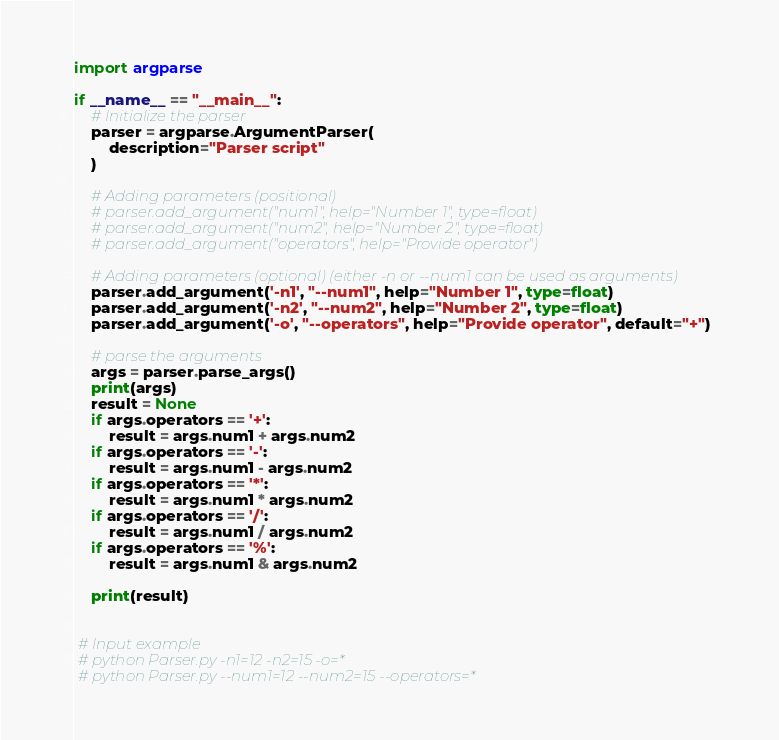Convert code to text. <code><loc_0><loc_0><loc_500><loc_500><_Python_>import argparse

if __name__ == "__main__":
    # Initialize the parser
    parser = argparse.ArgumentParser(
        description="Parser script"
    )

    # Adding parameters (positional)
    # parser.add_argument("num1", help="Number 1", type=float)
    # parser.add_argument("num2", help="Number 2", type=float)
    # parser.add_argument("operators", help="Provide operator")

    # Adding parameters (optional) (either -n or --num1 can be used as arguments)
    parser.add_argument('-n1', "--num1", help="Number 1", type=float)
    parser.add_argument('-n2', "--num2", help="Number 2", type=float)
    parser.add_argument('-o', "--operators", help="Provide operator", default="+")

    # parse the arguments
    args = parser.parse_args()
    print(args)
    result = None
    if args.operators == '+':
        result = args.num1 + args.num2
    if args.operators == '-':
        result = args.num1 - args.num2
    if args.operators == '*':
        result = args.num1 * args.num2
    if args.operators == '/':
        result = args.num1 / args.num2
    if args.operators == '%':
        result = args.num1 & args.num2

    print(result)


 # Input example
 # python Parser.py -n1=12 -n2=15 -o=*
 # python Parser.py --num1=12 --num2=15 --operators=*</code> 